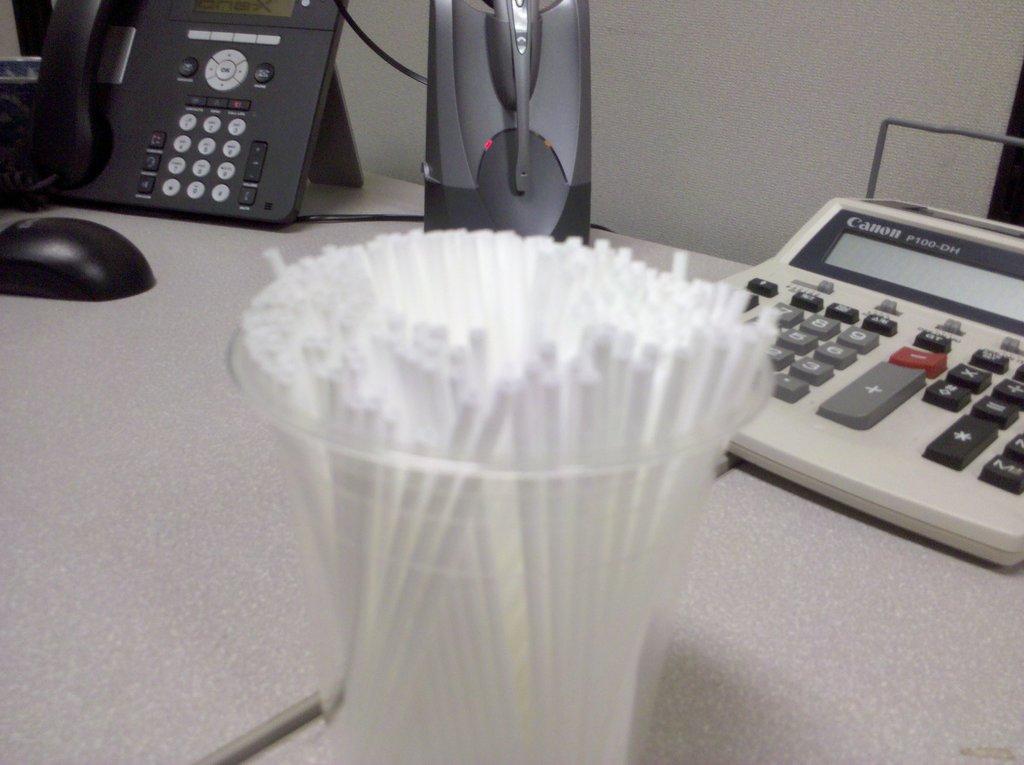Who made the calculator?
Your response must be concise. Canon. What model number is the calculator?
Your answer should be very brief. P100-dh. 